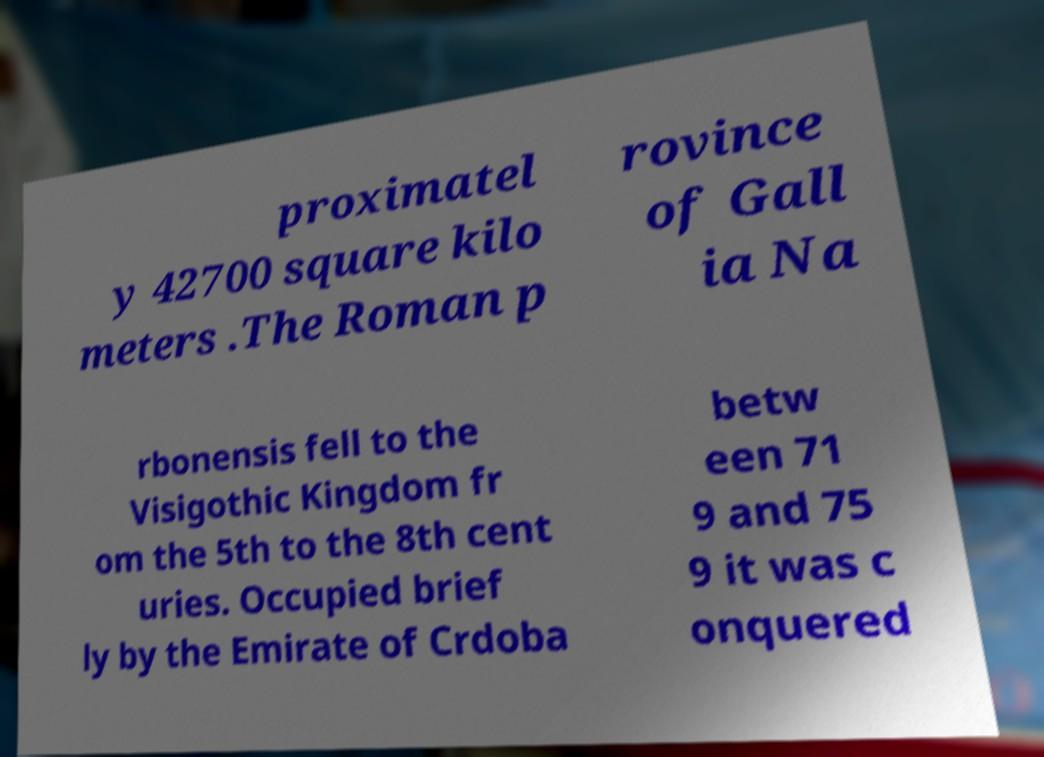For documentation purposes, I need the text within this image transcribed. Could you provide that? proximatel y 42700 square kilo meters .The Roman p rovince of Gall ia Na rbonensis fell to the Visigothic Kingdom fr om the 5th to the 8th cent uries. Occupied brief ly by the Emirate of Crdoba betw een 71 9 and 75 9 it was c onquered 